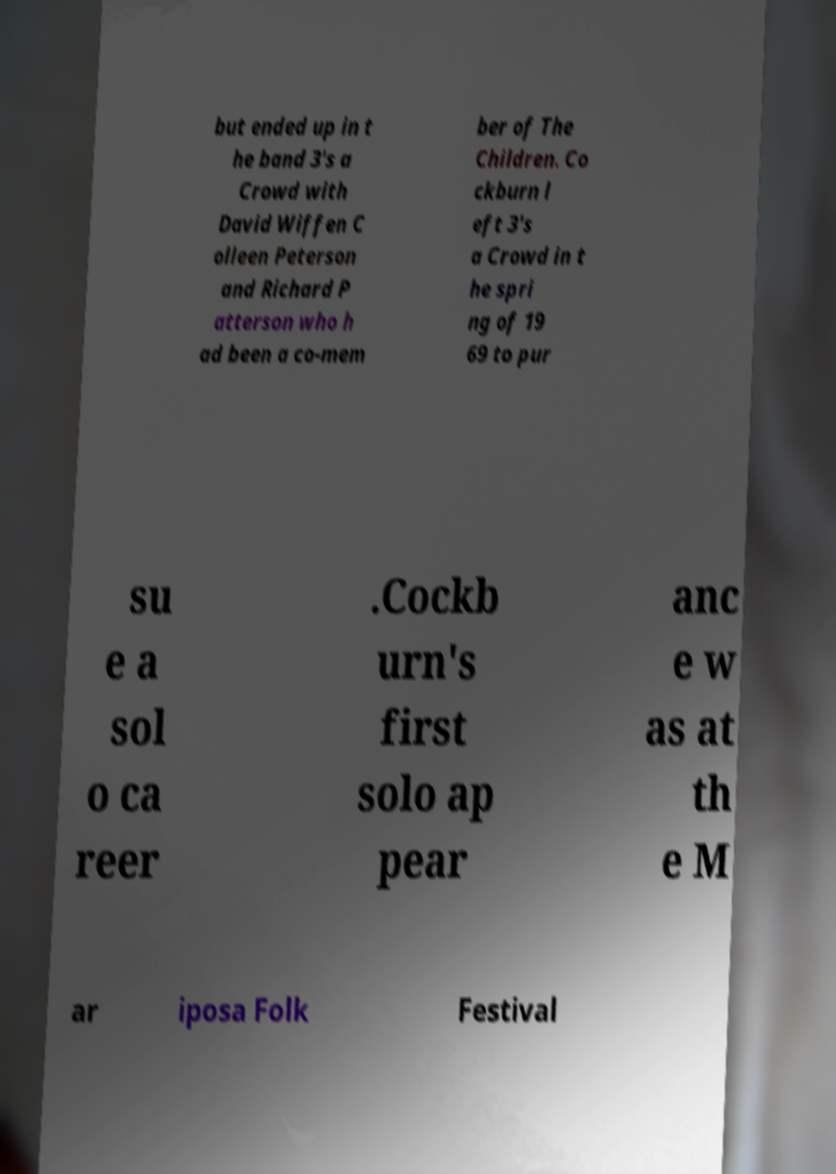Can you accurately transcribe the text from the provided image for me? but ended up in t he band 3's a Crowd with David Wiffen C olleen Peterson and Richard P atterson who h ad been a co-mem ber of The Children. Co ckburn l eft 3's a Crowd in t he spri ng of 19 69 to pur su e a sol o ca reer .Cockb urn's first solo ap pear anc e w as at th e M ar iposa Folk Festival 